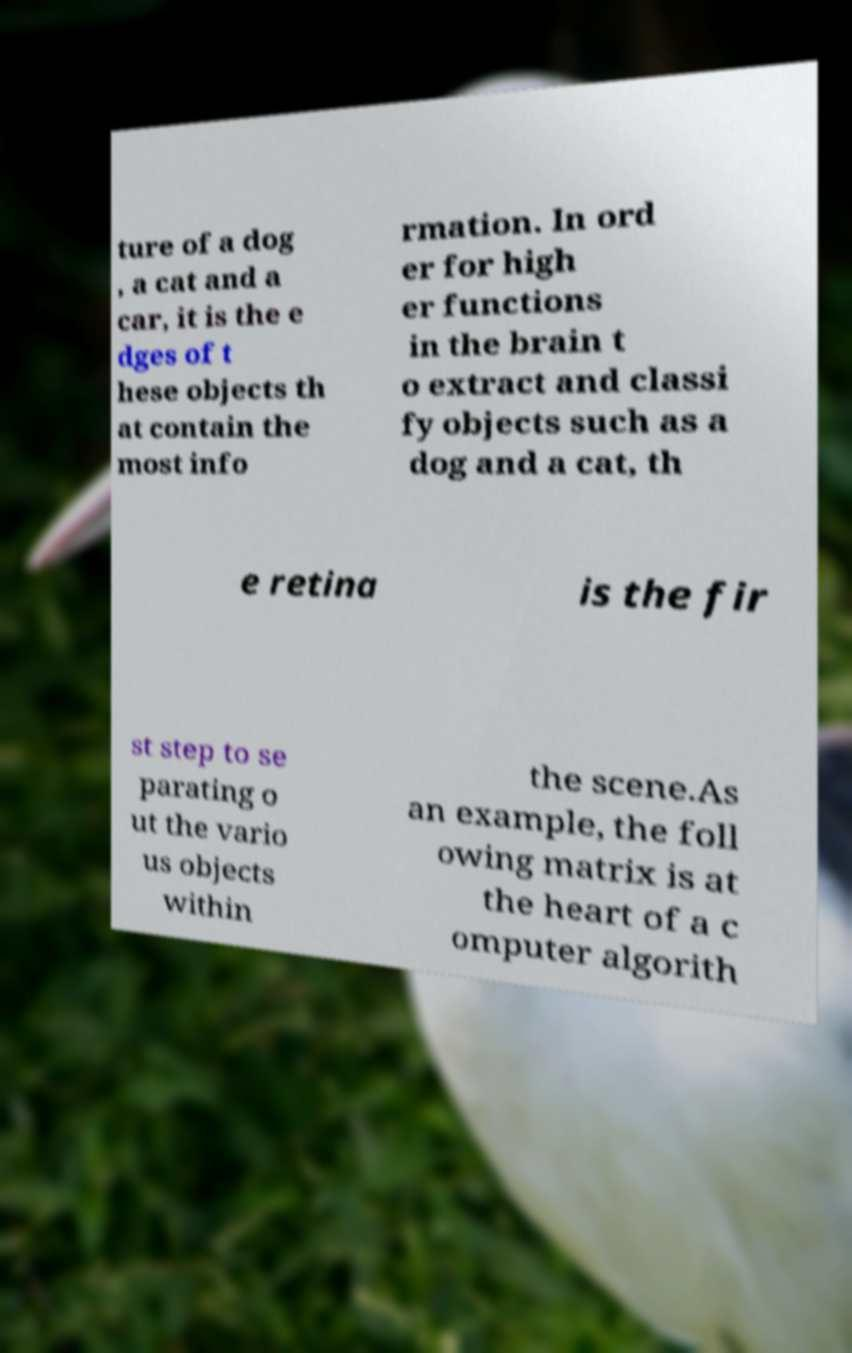I need the written content from this picture converted into text. Can you do that? ture of a dog , a cat and a car, it is the e dges of t hese objects th at contain the most info rmation. In ord er for high er functions in the brain t o extract and classi fy objects such as a dog and a cat, th e retina is the fir st step to se parating o ut the vario us objects within the scene.As an example, the foll owing matrix is at the heart of a c omputer algorith 